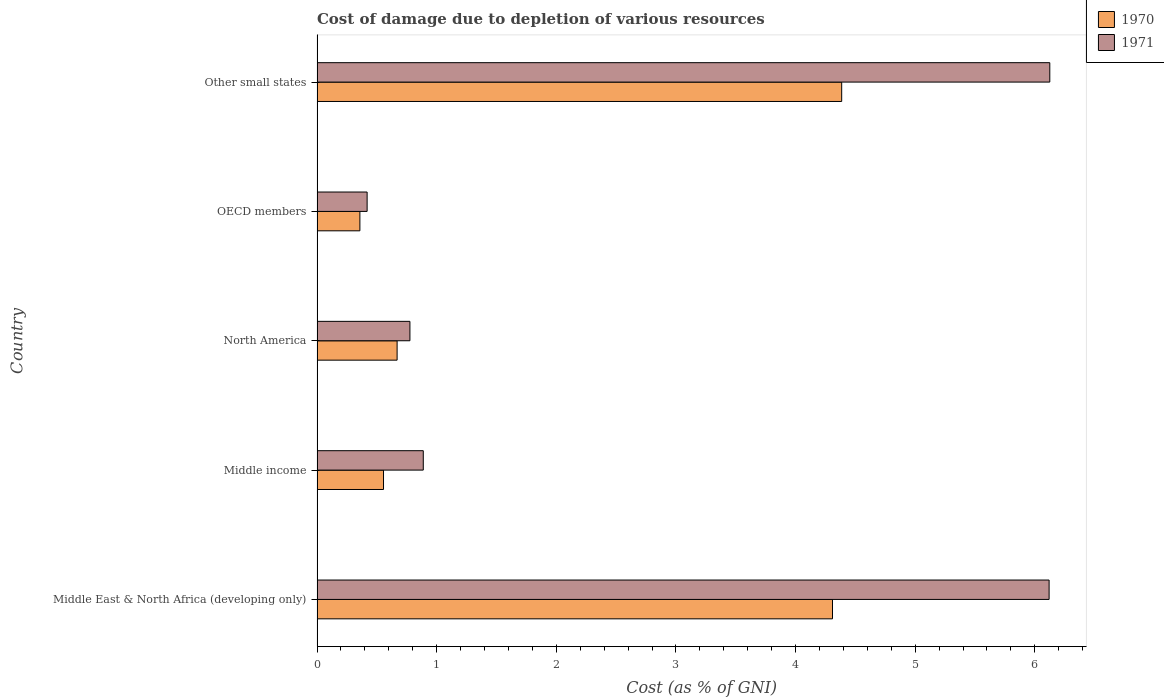How many groups of bars are there?
Keep it short and to the point. 5. Are the number of bars per tick equal to the number of legend labels?
Your response must be concise. Yes. Are the number of bars on each tick of the Y-axis equal?
Ensure brevity in your answer.  Yes. How many bars are there on the 3rd tick from the bottom?
Provide a succinct answer. 2. What is the label of the 2nd group of bars from the top?
Your answer should be compact. OECD members. In how many cases, is the number of bars for a given country not equal to the number of legend labels?
Provide a succinct answer. 0. What is the cost of damage caused due to the depletion of various resources in 1970 in Middle East & North Africa (developing only)?
Make the answer very short. 4.31. Across all countries, what is the maximum cost of damage caused due to the depletion of various resources in 1971?
Provide a succinct answer. 6.13. Across all countries, what is the minimum cost of damage caused due to the depletion of various resources in 1971?
Make the answer very short. 0.42. In which country was the cost of damage caused due to the depletion of various resources in 1970 maximum?
Provide a succinct answer. Other small states. What is the total cost of damage caused due to the depletion of various resources in 1971 in the graph?
Keep it short and to the point. 14.33. What is the difference between the cost of damage caused due to the depletion of various resources in 1971 in Middle income and that in OECD members?
Make the answer very short. 0.47. What is the difference between the cost of damage caused due to the depletion of various resources in 1971 in OECD members and the cost of damage caused due to the depletion of various resources in 1970 in Other small states?
Your answer should be compact. -3.97. What is the average cost of damage caused due to the depletion of various resources in 1970 per country?
Keep it short and to the point. 2.06. What is the difference between the cost of damage caused due to the depletion of various resources in 1971 and cost of damage caused due to the depletion of various resources in 1970 in OECD members?
Make the answer very short. 0.06. What is the ratio of the cost of damage caused due to the depletion of various resources in 1971 in OECD members to that in Other small states?
Offer a very short reply. 0.07. Is the cost of damage caused due to the depletion of various resources in 1971 in Middle income less than that in Other small states?
Keep it short and to the point. Yes. What is the difference between the highest and the second highest cost of damage caused due to the depletion of various resources in 1971?
Your answer should be very brief. 0.01. What is the difference between the highest and the lowest cost of damage caused due to the depletion of various resources in 1971?
Ensure brevity in your answer.  5.71. Is the sum of the cost of damage caused due to the depletion of various resources in 1970 in Middle East & North Africa (developing only) and North America greater than the maximum cost of damage caused due to the depletion of various resources in 1971 across all countries?
Your response must be concise. No. What does the 2nd bar from the top in OECD members represents?
Your answer should be very brief. 1970. How many countries are there in the graph?
Your answer should be very brief. 5. What is the difference between two consecutive major ticks on the X-axis?
Provide a succinct answer. 1. Does the graph contain grids?
Your answer should be very brief. No. Where does the legend appear in the graph?
Ensure brevity in your answer.  Top right. How are the legend labels stacked?
Offer a terse response. Vertical. What is the title of the graph?
Give a very brief answer. Cost of damage due to depletion of various resources. Does "1985" appear as one of the legend labels in the graph?
Provide a short and direct response. No. What is the label or title of the X-axis?
Your response must be concise. Cost (as % of GNI). What is the Cost (as % of GNI) in 1970 in Middle East & North Africa (developing only)?
Give a very brief answer. 4.31. What is the Cost (as % of GNI) of 1971 in Middle East & North Africa (developing only)?
Ensure brevity in your answer.  6.12. What is the Cost (as % of GNI) of 1970 in Middle income?
Keep it short and to the point. 0.56. What is the Cost (as % of GNI) in 1971 in Middle income?
Your answer should be very brief. 0.89. What is the Cost (as % of GNI) of 1970 in North America?
Provide a short and direct response. 0.67. What is the Cost (as % of GNI) in 1971 in North America?
Keep it short and to the point. 0.78. What is the Cost (as % of GNI) in 1970 in OECD members?
Keep it short and to the point. 0.36. What is the Cost (as % of GNI) of 1971 in OECD members?
Your answer should be compact. 0.42. What is the Cost (as % of GNI) of 1970 in Other small states?
Keep it short and to the point. 4.39. What is the Cost (as % of GNI) in 1971 in Other small states?
Offer a very short reply. 6.13. Across all countries, what is the maximum Cost (as % of GNI) of 1970?
Your answer should be very brief. 4.39. Across all countries, what is the maximum Cost (as % of GNI) in 1971?
Your answer should be compact. 6.13. Across all countries, what is the minimum Cost (as % of GNI) of 1970?
Your response must be concise. 0.36. Across all countries, what is the minimum Cost (as % of GNI) of 1971?
Offer a terse response. 0.42. What is the total Cost (as % of GNI) of 1970 in the graph?
Provide a succinct answer. 10.28. What is the total Cost (as % of GNI) of 1971 in the graph?
Keep it short and to the point. 14.33. What is the difference between the Cost (as % of GNI) in 1970 in Middle East & North Africa (developing only) and that in Middle income?
Offer a very short reply. 3.75. What is the difference between the Cost (as % of GNI) in 1971 in Middle East & North Africa (developing only) and that in Middle income?
Ensure brevity in your answer.  5.23. What is the difference between the Cost (as % of GNI) of 1970 in Middle East & North Africa (developing only) and that in North America?
Your answer should be compact. 3.64. What is the difference between the Cost (as % of GNI) of 1971 in Middle East & North Africa (developing only) and that in North America?
Keep it short and to the point. 5.34. What is the difference between the Cost (as % of GNI) of 1970 in Middle East & North Africa (developing only) and that in OECD members?
Provide a succinct answer. 3.95. What is the difference between the Cost (as % of GNI) of 1971 in Middle East & North Africa (developing only) and that in OECD members?
Ensure brevity in your answer.  5.7. What is the difference between the Cost (as % of GNI) of 1970 in Middle East & North Africa (developing only) and that in Other small states?
Ensure brevity in your answer.  -0.08. What is the difference between the Cost (as % of GNI) in 1971 in Middle East & North Africa (developing only) and that in Other small states?
Your answer should be compact. -0.01. What is the difference between the Cost (as % of GNI) in 1970 in Middle income and that in North America?
Your answer should be compact. -0.11. What is the difference between the Cost (as % of GNI) in 1971 in Middle income and that in North America?
Offer a terse response. 0.11. What is the difference between the Cost (as % of GNI) of 1970 in Middle income and that in OECD members?
Your answer should be compact. 0.2. What is the difference between the Cost (as % of GNI) of 1971 in Middle income and that in OECD members?
Offer a terse response. 0.47. What is the difference between the Cost (as % of GNI) of 1970 in Middle income and that in Other small states?
Offer a very short reply. -3.83. What is the difference between the Cost (as % of GNI) of 1971 in Middle income and that in Other small states?
Keep it short and to the point. -5.24. What is the difference between the Cost (as % of GNI) in 1970 in North America and that in OECD members?
Offer a terse response. 0.31. What is the difference between the Cost (as % of GNI) in 1971 in North America and that in OECD members?
Offer a terse response. 0.36. What is the difference between the Cost (as % of GNI) of 1970 in North America and that in Other small states?
Offer a very short reply. -3.72. What is the difference between the Cost (as % of GNI) in 1971 in North America and that in Other small states?
Provide a succinct answer. -5.35. What is the difference between the Cost (as % of GNI) of 1970 in OECD members and that in Other small states?
Your answer should be very brief. -4.03. What is the difference between the Cost (as % of GNI) in 1971 in OECD members and that in Other small states?
Your answer should be very brief. -5.71. What is the difference between the Cost (as % of GNI) in 1970 in Middle East & North Africa (developing only) and the Cost (as % of GNI) in 1971 in Middle income?
Offer a terse response. 3.42. What is the difference between the Cost (as % of GNI) of 1970 in Middle East & North Africa (developing only) and the Cost (as % of GNI) of 1971 in North America?
Provide a succinct answer. 3.53. What is the difference between the Cost (as % of GNI) of 1970 in Middle East & North Africa (developing only) and the Cost (as % of GNI) of 1971 in OECD members?
Offer a terse response. 3.89. What is the difference between the Cost (as % of GNI) in 1970 in Middle East & North Africa (developing only) and the Cost (as % of GNI) in 1971 in Other small states?
Your response must be concise. -1.82. What is the difference between the Cost (as % of GNI) in 1970 in Middle income and the Cost (as % of GNI) in 1971 in North America?
Your response must be concise. -0.22. What is the difference between the Cost (as % of GNI) in 1970 in Middle income and the Cost (as % of GNI) in 1971 in OECD members?
Offer a very short reply. 0.14. What is the difference between the Cost (as % of GNI) of 1970 in Middle income and the Cost (as % of GNI) of 1971 in Other small states?
Your answer should be compact. -5.57. What is the difference between the Cost (as % of GNI) in 1970 in North America and the Cost (as % of GNI) in 1971 in OECD members?
Offer a terse response. 0.25. What is the difference between the Cost (as % of GNI) of 1970 in North America and the Cost (as % of GNI) of 1971 in Other small states?
Ensure brevity in your answer.  -5.46. What is the difference between the Cost (as % of GNI) in 1970 in OECD members and the Cost (as % of GNI) in 1971 in Other small states?
Offer a very short reply. -5.77. What is the average Cost (as % of GNI) in 1970 per country?
Offer a terse response. 2.06. What is the average Cost (as % of GNI) of 1971 per country?
Offer a terse response. 2.87. What is the difference between the Cost (as % of GNI) in 1970 and Cost (as % of GNI) in 1971 in Middle East & North Africa (developing only)?
Your answer should be compact. -1.81. What is the difference between the Cost (as % of GNI) of 1970 and Cost (as % of GNI) of 1971 in Middle income?
Make the answer very short. -0.33. What is the difference between the Cost (as % of GNI) of 1970 and Cost (as % of GNI) of 1971 in North America?
Give a very brief answer. -0.11. What is the difference between the Cost (as % of GNI) in 1970 and Cost (as % of GNI) in 1971 in OECD members?
Keep it short and to the point. -0.06. What is the difference between the Cost (as % of GNI) in 1970 and Cost (as % of GNI) in 1971 in Other small states?
Offer a terse response. -1.74. What is the ratio of the Cost (as % of GNI) in 1970 in Middle East & North Africa (developing only) to that in Middle income?
Your answer should be compact. 7.76. What is the ratio of the Cost (as % of GNI) in 1971 in Middle East & North Africa (developing only) to that in Middle income?
Your answer should be very brief. 6.89. What is the ratio of the Cost (as % of GNI) in 1970 in Middle East & North Africa (developing only) to that in North America?
Ensure brevity in your answer.  6.44. What is the ratio of the Cost (as % of GNI) of 1971 in Middle East & North Africa (developing only) to that in North America?
Your response must be concise. 7.88. What is the ratio of the Cost (as % of GNI) in 1970 in Middle East & North Africa (developing only) to that in OECD members?
Ensure brevity in your answer.  12.03. What is the ratio of the Cost (as % of GNI) in 1971 in Middle East & North Africa (developing only) to that in OECD members?
Provide a short and direct response. 14.62. What is the ratio of the Cost (as % of GNI) of 1970 in Middle East & North Africa (developing only) to that in Other small states?
Offer a very short reply. 0.98. What is the ratio of the Cost (as % of GNI) in 1971 in Middle East & North Africa (developing only) to that in Other small states?
Make the answer very short. 1. What is the ratio of the Cost (as % of GNI) of 1970 in Middle income to that in North America?
Keep it short and to the point. 0.83. What is the ratio of the Cost (as % of GNI) in 1971 in Middle income to that in North America?
Provide a succinct answer. 1.14. What is the ratio of the Cost (as % of GNI) in 1970 in Middle income to that in OECD members?
Provide a short and direct response. 1.55. What is the ratio of the Cost (as % of GNI) in 1971 in Middle income to that in OECD members?
Your answer should be compact. 2.12. What is the ratio of the Cost (as % of GNI) of 1970 in Middle income to that in Other small states?
Give a very brief answer. 0.13. What is the ratio of the Cost (as % of GNI) of 1971 in Middle income to that in Other small states?
Make the answer very short. 0.14. What is the ratio of the Cost (as % of GNI) of 1970 in North America to that in OECD members?
Keep it short and to the point. 1.87. What is the ratio of the Cost (as % of GNI) of 1971 in North America to that in OECD members?
Provide a short and direct response. 1.85. What is the ratio of the Cost (as % of GNI) of 1970 in North America to that in Other small states?
Ensure brevity in your answer.  0.15. What is the ratio of the Cost (as % of GNI) in 1971 in North America to that in Other small states?
Give a very brief answer. 0.13. What is the ratio of the Cost (as % of GNI) in 1970 in OECD members to that in Other small states?
Provide a succinct answer. 0.08. What is the ratio of the Cost (as % of GNI) of 1971 in OECD members to that in Other small states?
Offer a very short reply. 0.07. What is the difference between the highest and the second highest Cost (as % of GNI) in 1970?
Make the answer very short. 0.08. What is the difference between the highest and the second highest Cost (as % of GNI) of 1971?
Your answer should be compact. 0.01. What is the difference between the highest and the lowest Cost (as % of GNI) of 1970?
Your answer should be compact. 4.03. What is the difference between the highest and the lowest Cost (as % of GNI) of 1971?
Offer a very short reply. 5.71. 